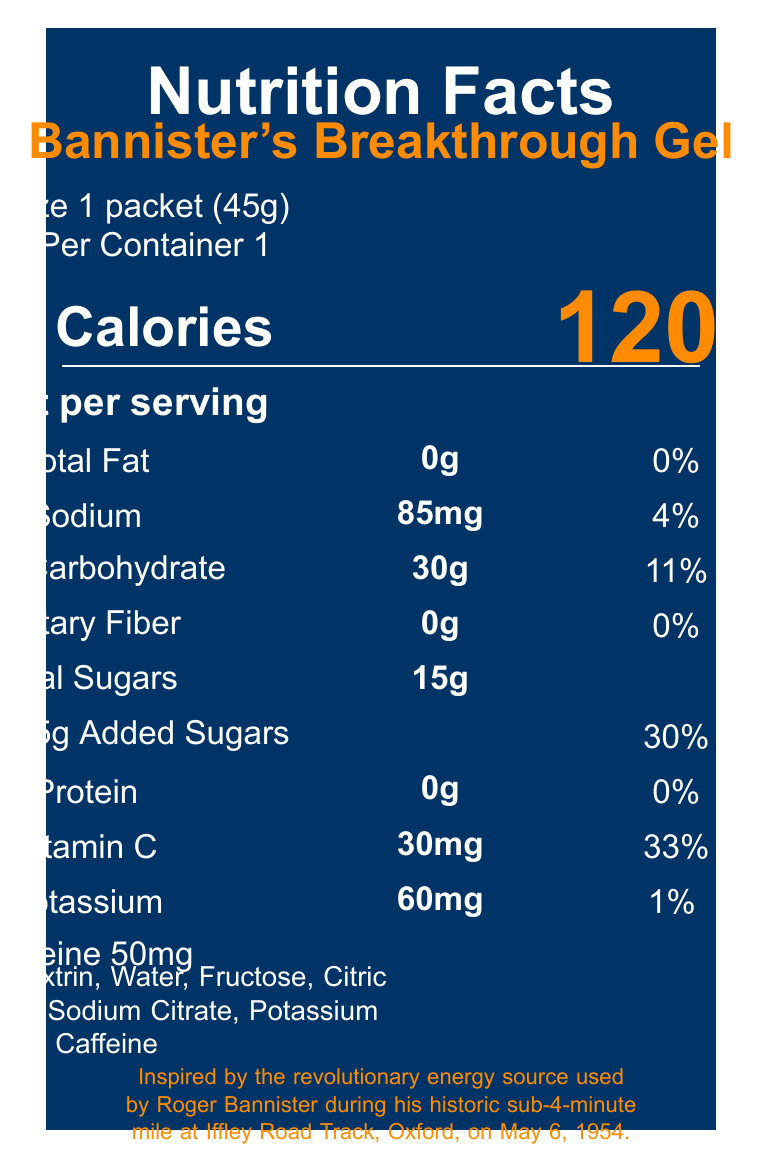what is the serving size for Bannister's Breakthrough Gel? The document clearly states the serving size as "1 packet (45g)".
Answer: 1 packet (45g) how many calories are in one serving of Bannister's Breakthrough Gel? The document lists the calories per serving as 120.
Answer: 120 what is the amount of total fat per serving? The document specifies that there is no total fat in a serving of Bannister's Breakthrough Gel.
Answer: 0g what percentage of the Daily Value for sodium does one serving provide? The document states that one serving provides 4% of the Daily Value for sodium.
Answer: 4% which of the following ingredients is found in Bannister's Breakthrough Gel? A. Sucrose B. Fructose C. Glucose The ingredients section lists Fructose specifically.
Answer: B what is the daily value percentage of vitamin C provided by Bannister's Breakthrough Gel? According to the document, the vitamin C content provides 33% of the Daily Value.
Answer: 33% how much caffeine does Bannister's Breakthrough Gel contain? The document mentions that there is 50mg of caffeine per serving.
Answer: 50mg what is the total amount of sugars in one serving? The document lists the total sugars per serving as 15g.
Answer: 15g is the Bannister's Breakthrough Gel facility free from soy and milk products? The document mentions that the gel is produced in a facility that also processes soy and milk products.
Answer: No describe the main idea of the document. The document centers around the detailed nutritional facts of the gel used by Roger Bannister, highlighting its ingredients, dietary content, and historical relevance.
Answer: The document provides nutritional information for Bannister's Breakthrough Gel, including serving size, calories, and nutrient contents. It also lists ingredients, storage instructions, and historical significance linking it to Roger Bannister's historic 4-minute mile. where was Bannister's Breakthrough Gel manufactured? The document specifies that the manufacturer is Iffley Road Sports Nutrition, Oxford, England.
Answer: Oxford, England what is the total carbohydrate content per serving? The total carbohydrate content per serving is listed as 30g in the document.
Answer: 30g Roger Bannister broke the 4-minute mile on which date? The document states that this historic event took place on May 6, 1954.
Answer: May 6, 1954 how should Bannister's Breakthrough Gel be stored? A. In the refrigerator B. In a cool, dry place C. At room temperature The storage instructions specify that it should be stored in a cool, dry place.
Answer: B does Bannister's Breakthrough Gel contain dietary fiber? The document lists the amount of dietary fiber as 0g, indicating it does not contain any.
Answer: No How does the package highlight the historical significance of the gel? The historical note section states that the gel was inspired by the revolutionary energy source used by Roger Bannister during his historic sub-4-minute mile.
Answer: It mentions it was inspired by the energy source used by Roger Bannister. What type of acid is included in the ingredients? The ingredients section lists both Citric Acid and Ascorbic Acid.
Answer: Citric Acid and Ascorbic Acid Can someone use Bannister's Breakthrough Gel after 24 hours of opening? The storage instructions clearly mention to use the product within 24 hours of opening.
Answer: No What is the daily value percentage of added sugars per serving? The document specifies that the added sugars content constitutes 30% of the daily value.
Answer: 30% How many servings does one container of Bannister's Breakthrough Gel provide? According to the document, each container provides 1 serving.
Answer: 1 What is the unique color naming used in the document? The document includes specific color names bannisterblue and trackorange used in the design.
Answer: bannisterblue and trackorange 